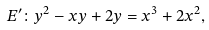<formula> <loc_0><loc_0><loc_500><loc_500>E ^ { \prime } \colon y ^ { 2 } - x y + 2 y = x ^ { 3 } + 2 x ^ { 2 } ,</formula> 